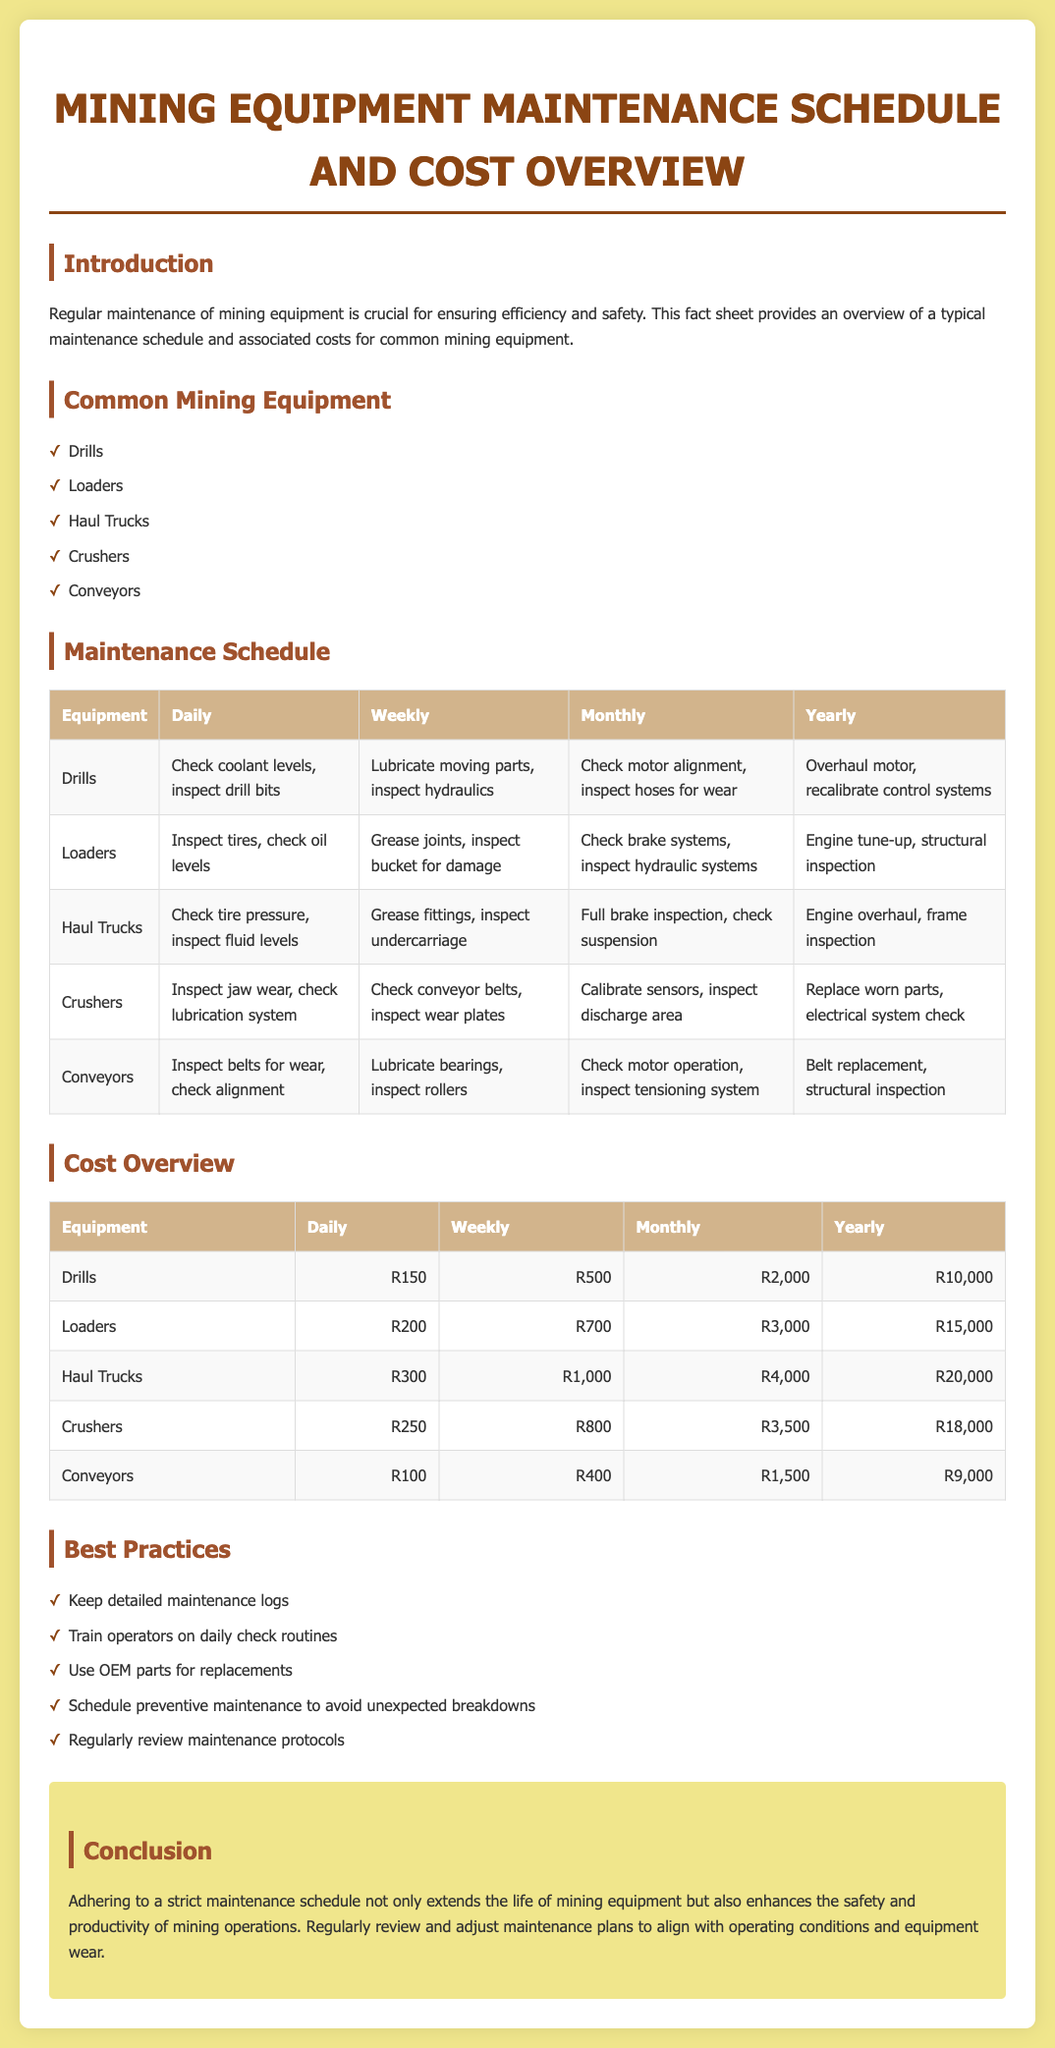What is the daily maintenance cost for Drills? The daily maintenance cost for Drills is explicitly stated in the cost overview section.
Answer: R150 How often should Crushers undergo a full brake inspection? The frequency for a full brake inspection of Crushers is indicated in the maintenance schedule table.
Answer: Monthly What is the annual maintenance cost for Haul Trucks? The annual maintenance cost for Haul Trucks is found in the cost overview table.
Answer: R20,000 List one of the common mining equipment types mentioned. The document lists several types of mining equipment, which is detailed in the common equipment section.
Answer: Drills What maintenance is performed monthly on Loaders? The specific monthly maintenance tasks for Loaders are provided in the maintenance schedule table.
Answer: Check brake systems, inspect hydraulic systems What maintenance practice helps avoid unexpected breakdowns? The best practices listed include several recommendations for maintenance.
Answer: Schedule preventive maintenance What is a key benefit of adhering to a strict maintenance schedule? The conclusion section outlines the benefits of strict maintenance schedules.
Answer: Extends life of mining equipment How many types of common mining equipment are listed? The number of common mining equipment types is given in the corresponding list in the document.
Answer: Five 